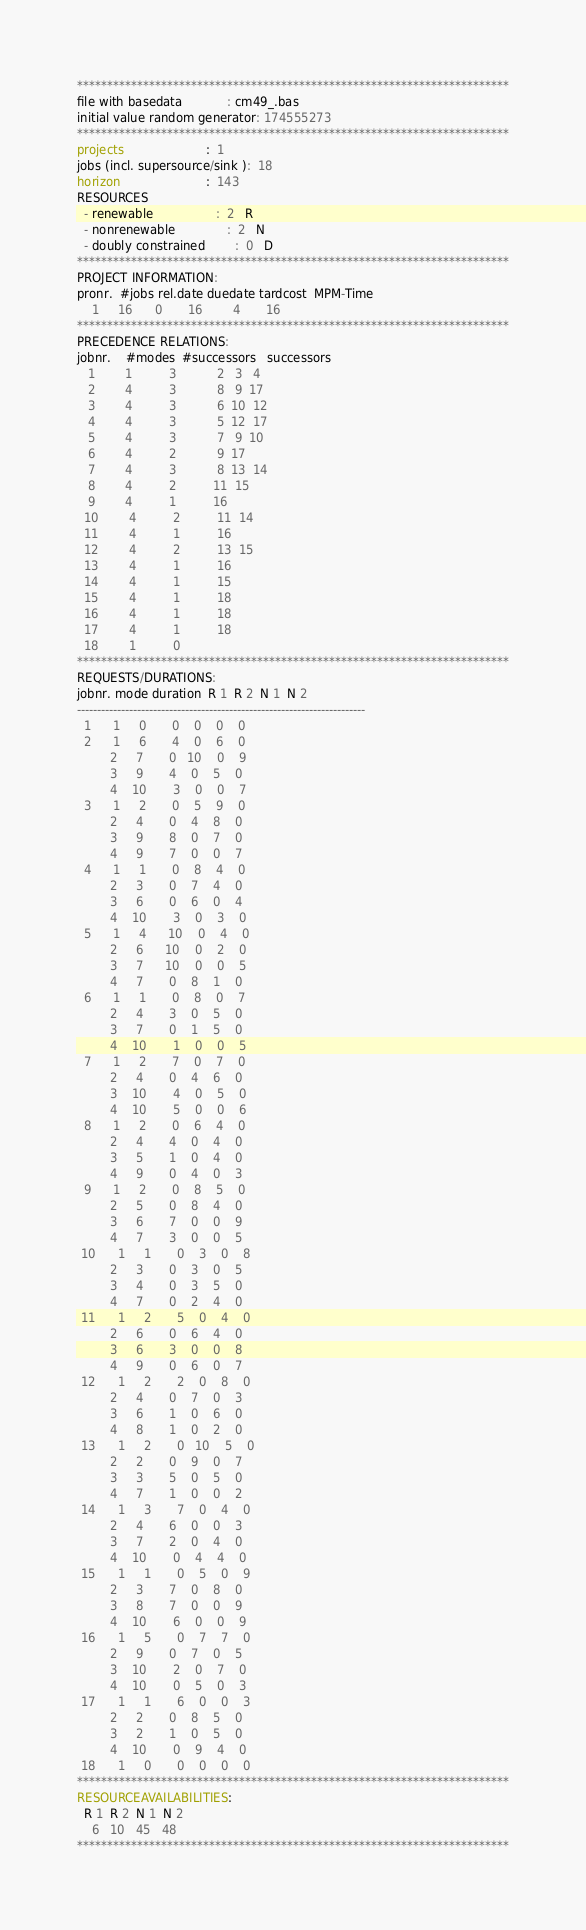Convert code to text. <code><loc_0><loc_0><loc_500><loc_500><_ObjectiveC_>************************************************************************
file with basedata            : cm49_.bas
initial value random generator: 174555273
************************************************************************
projects                      :  1
jobs (incl. supersource/sink ):  18
horizon                       :  143
RESOURCES
  - renewable                 :  2   R
  - nonrenewable              :  2   N
  - doubly constrained        :  0   D
************************************************************************
PROJECT INFORMATION:
pronr.  #jobs rel.date duedate tardcost  MPM-Time
    1     16      0       16        4       16
************************************************************************
PRECEDENCE RELATIONS:
jobnr.    #modes  #successors   successors
   1        1          3           2   3   4
   2        4          3           8   9  17
   3        4          3           6  10  12
   4        4          3           5  12  17
   5        4          3           7   9  10
   6        4          2           9  17
   7        4          3           8  13  14
   8        4          2          11  15
   9        4          1          16
  10        4          2          11  14
  11        4          1          16
  12        4          2          13  15
  13        4          1          16
  14        4          1          15
  15        4          1          18
  16        4          1          18
  17        4          1          18
  18        1          0        
************************************************************************
REQUESTS/DURATIONS:
jobnr. mode duration  R 1  R 2  N 1  N 2
------------------------------------------------------------------------
  1      1     0       0    0    0    0
  2      1     6       4    0    6    0
         2     7       0   10    0    9
         3     9       4    0    5    0
         4    10       3    0    0    7
  3      1     2       0    5    9    0
         2     4       0    4    8    0
         3     9       8    0    7    0
         4     9       7    0    0    7
  4      1     1       0    8    4    0
         2     3       0    7    4    0
         3     6       0    6    0    4
         4    10       3    0    3    0
  5      1     4      10    0    4    0
         2     6      10    0    2    0
         3     7      10    0    0    5
         4     7       0    8    1    0
  6      1     1       0    8    0    7
         2     4       3    0    5    0
         3     7       0    1    5    0
         4    10       1    0    0    5
  7      1     2       7    0    7    0
         2     4       0    4    6    0
         3    10       4    0    5    0
         4    10       5    0    0    6
  8      1     2       0    6    4    0
         2     4       4    0    4    0
         3     5       1    0    4    0
         4     9       0    4    0    3
  9      1     2       0    8    5    0
         2     5       0    8    4    0
         3     6       7    0    0    9
         4     7       3    0    0    5
 10      1     1       0    3    0    8
         2     3       0    3    0    5
         3     4       0    3    5    0
         4     7       0    2    4    0
 11      1     2       5    0    4    0
         2     6       0    6    4    0
         3     6       3    0    0    8
         4     9       0    6    0    7
 12      1     2       2    0    8    0
         2     4       0    7    0    3
         3     6       1    0    6    0
         4     8       1    0    2    0
 13      1     2       0   10    5    0
         2     2       0    9    0    7
         3     3       5    0    5    0
         4     7       1    0    0    2
 14      1     3       7    0    4    0
         2     4       6    0    0    3
         3     7       2    0    4    0
         4    10       0    4    4    0
 15      1     1       0    5    0    9
         2     3       7    0    8    0
         3     8       7    0    0    9
         4    10       6    0    0    9
 16      1     5       0    7    7    0
         2     9       0    7    0    5
         3    10       2    0    7    0
         4    10       0    5    0    3
 17      1     1       6    0    0    3
         2     2       0    8    5    0
         3     2       1    0    5    0
         4    10       0    9    4    0
 18      1     0       0    0    0    0
************************************************************************
RESOURCEAVAILABILITIES:
  R 1  R 2  N 1  N 2
    6   10   45   48
************************************************************************
</code> 